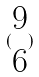Convert formula to latex. <formula><loc_0><loc_0><loc_500><loc_500>( \begin{matrix} 9 \\ 6 \end{matrix} )</formula> 